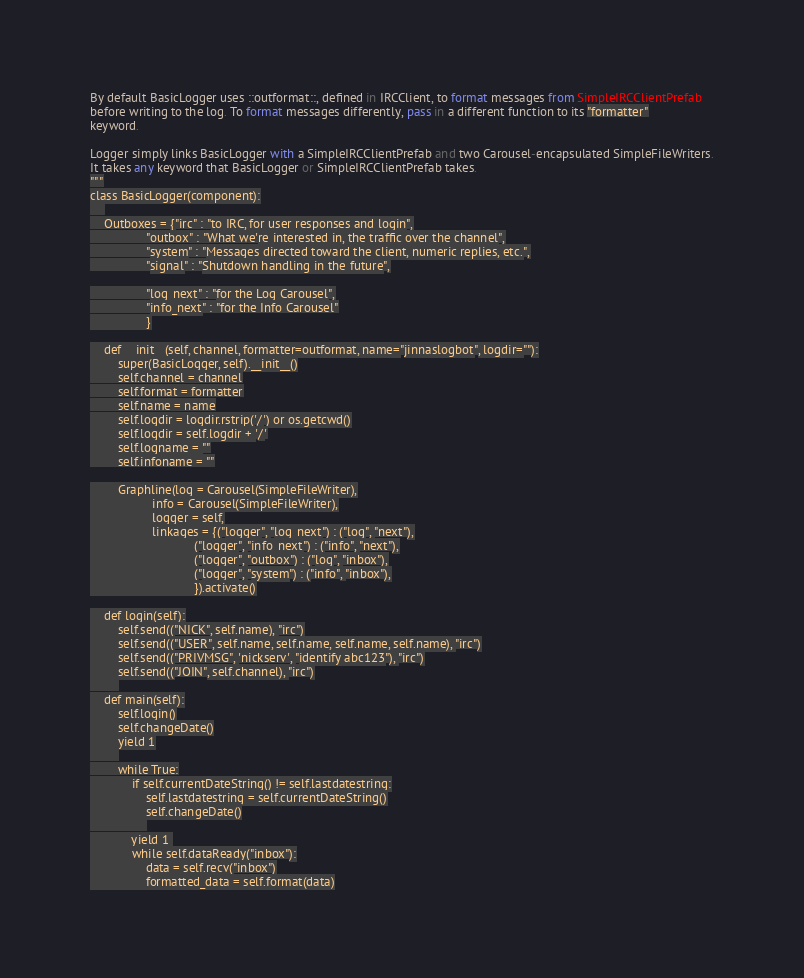<code> <loc_0><loc_0><loc_500><loc_500><_Python_>By default BasicLogger uses ::outformat::, defined in IRCClient, to format messages from SimpleIRCClientPrefab
before writing to the log. To format messages differently, pass in a different function to its "formatter"
keyword. 

Logger simply links BasicLogger with a SimpleIRCClientPrefab and two Carousel-encapsulated SimpleFileWriters.
It takes any keyword that BasicLogger or SimpleIRCClientPrefab takes. 
"""
class BasicLogger(component):
    
    Outboxes = {"irc" : "to IRC, for user responses and login",
                "outbox" : "What we're interested in, the traffic over the channel",
                "system" : "Messages directed toward the client, numeric replies, etc.",
                "signal" : "Shutdown handling in the future",

                "log_next" : "for the Log Carousel",
                "info_next" : "for the Info Carousel"
                }

    def __init__(self, channel, formatter=outformat, name="jinnaslogbot", logdir=""):
        super(BasicLogger, self).__init__()
        self.channel = channel
        self.format = formatter
        self.name = name
        self.logdir = logdir.rstrip('/') or os.getcwd()
        self.logdir = self.logdir + '/'
        self.logname = ""
        self.infoname = ""

        Graphline(log = Carousel(SimpleFileWriter),
                  info = Carousel(SimpleFileWriter),
                  logger = self,
                  linkages = {("logger", "log_next") : ("log", "next"),
                              ("logger", "info_next") : ("info", "next"),
                              ("logger", "outbox") : ("log", "inbox"),
                              ("logger", "system") : ("info", "inbox"),
                              }).activate()

    def login(self):
        self.send(("NICK", self.name), "irc")
        self.send(("USER", self.name, self.name, self.name, self.name), "irc")
        self.send(("PRIVMSG", 'nickserv', "identify abc123"), "irc")
        self.send(("JOIN", self.channel), "irc")
        
    def main(self):
        self.login()
        self.changeDate()
        yield 1
        
        while True:
            if self.currentDateString() != self.lastdatestring:
                self.lastdatestring = self.currentDateString()
                self.changeDate()
                
            yield 1 
            while self.dataReady("inbox"):
                data = self.recv("inbox")
                formatted_data = self.format(data)</code> 